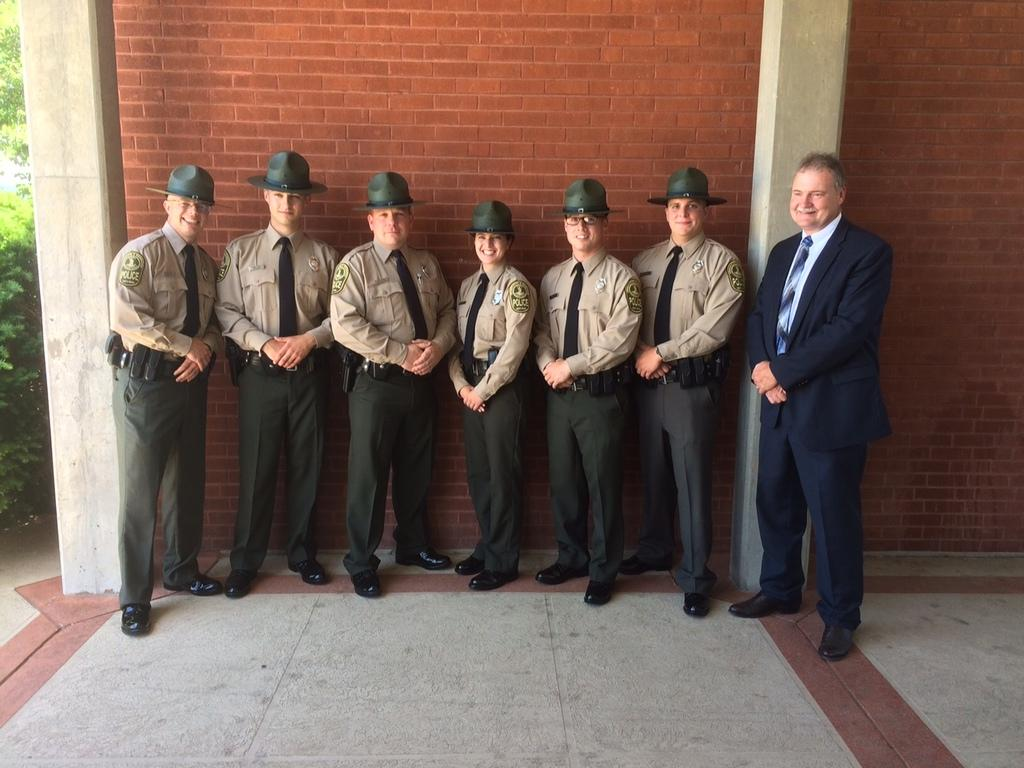How many people are in the group in the image? There is a group of people in the image. What are most of the people in the group wearing? Most of the people in the group are wearing hats. What can be seen in the background of the image? There is a wall in the background of the image. How many horses are present in the image? There are no horses present in the image. What type of land can be seen in the image? The image does not depict any land; it features a group of people and a wall in the background. 